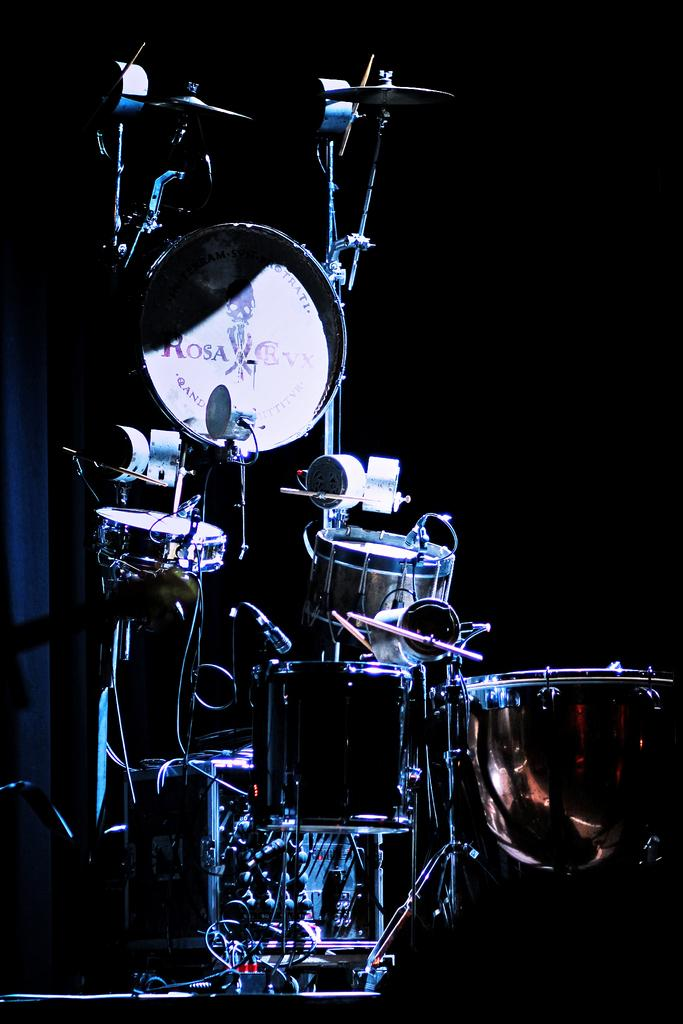What type of object is the main subject in the image? There is a musical instrument in the image. What type of knowledge can be gained from the musical instrument in the image? The image does not convey any specific knowledge about the musical instrument; it only shows the instrument itself. 